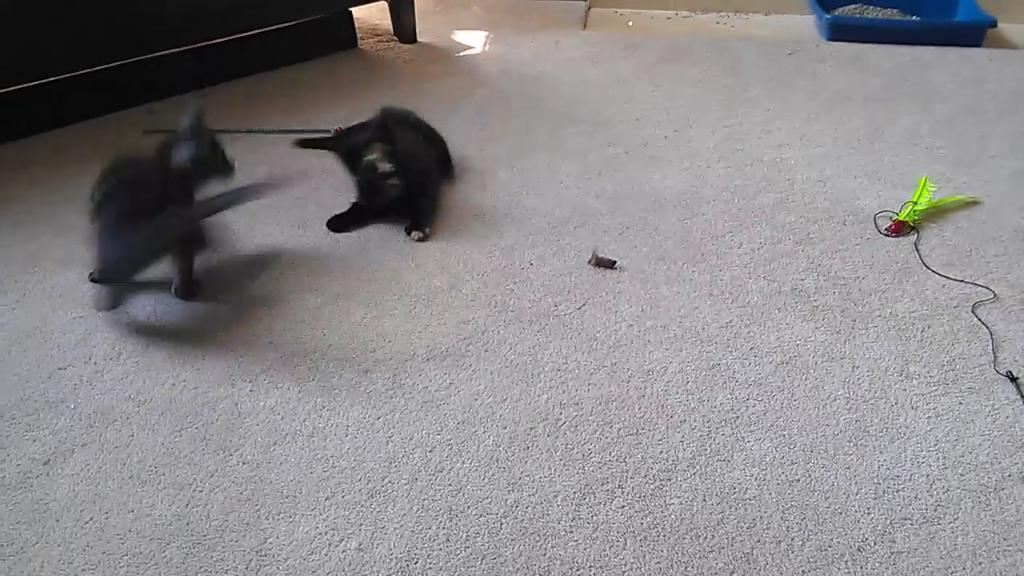How many cats are present in the image? There are two cats in the image. What is located at the bottom of the image? There is a floor mat at the bottom of the image. What can be seen to the right of the image? There is a wire to the right of the image. What object is blue and located in the front of the image? There is a blue color tray in the front of the image. What type of coal is being used by the cats in the image? There is no coal present in the image; it features two cats and other objects. How many oranges are visible in the image? There are no oranges present in the image. 